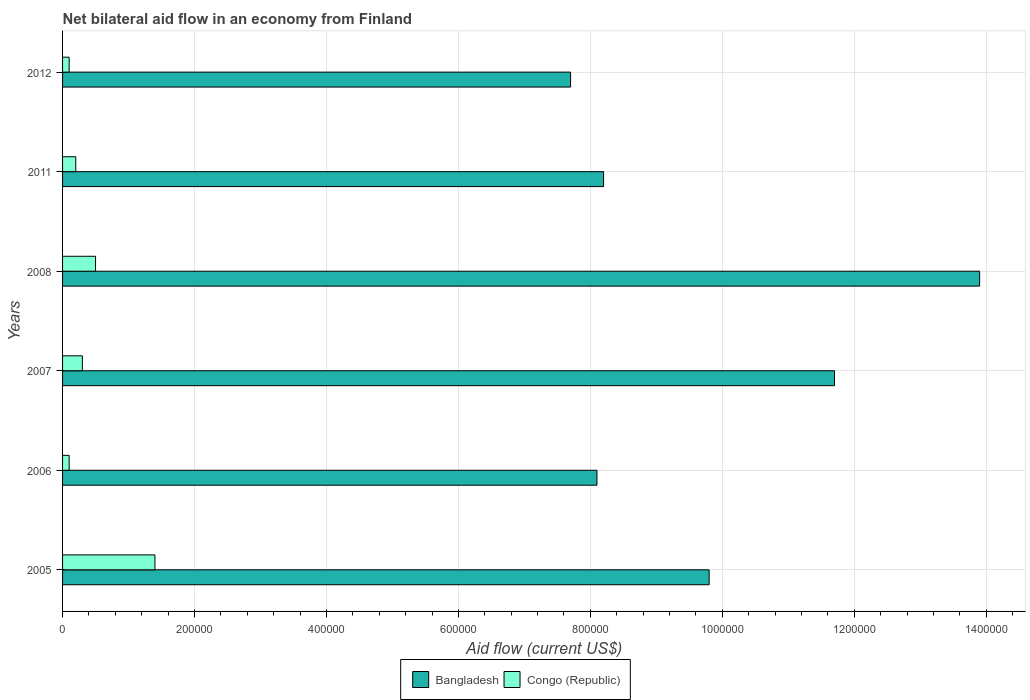How many different coloured bars are there?
Your response must be concise. 2. How many groups of bars are there?
Offer a very short reply. 6. Are the number of bars on each tick of the Y-axis equal?
Offer a very short reply. Yes. What is the label of the 2nd group of bars from the top?
Your response must be concise. 2011. What is the net bilateral aid flow in Bangladesh in 2008?
Your response must be concise. 1.39e+06. Across all years, what is the maximum net bilateral aid flow in Bangladesh?
Offer a terse response. 1.39e+06. Across all years, what is the minimum net bilateral aid flow in Bangladesh?
Ensure brevity in your answer.  7.70e+05. In which year was the net bilateral aid flow in Bangladesh minimum?
Provide a short and direct response. 2012. What is the total net bilateral aid flow in Bangladesh in the graph?
Ensure brevity in your answer.  5.94e+06. What is the difference between the net bilateral aid flow in Bangladesh in 2006 and the net bilateral aid flow in Congo (Republic) in 2007?
Your answer should be compact. 7.80e+05. What is the average net bilateral aid flow in Bangladesh per year?
Offer a terse response. 9.90e+05. In the year 2012, what is the difference between the net bilateral aid flow in Congo (Republic) and net bilateral aid flow in Bangladesh?
Provide a short and direct response. -7.60e+05. In how many years, is the net bilateral aid flow in Bangladesh greater than 320000 US$?
Provide a succinct answer. 6. What is the ratio of the net bilateral aid flow in Bangladesh in 2005 to that in 2012?
Offer a very short reply. 1.27. What is the difference between the highest and the lowest net bilateral aid flow in Congo (Republic)?
Give a very brief answer. 1.30e+05. In how many years, is the net bilateral aid flow in Bangladesh greater than the average net bilateral aid flow in Bangladesh taken over all years?
Give a very brief answer. 2. Is the sum of the net bilateral aid flow in Bangladesh in 2005 and 2011 greater than the maximum net bilateral aid flow in Congo (Republic) across all years?
Make the answer very short. Yes. What does the 1st bar from the top in 2005 represents?
Ensure brevity in your answer.  Congo (Republic). Are the values on the major ticks of X-axis written in scientific E-notation?
Ensure brevity in your answer.  No. Does the graph contain grids?
Make the answer very short. Yes. How many legend labels are there?
Offer a very short reply. 2. How are the legend labels stacked?
Offer a very short reply. Horizontal. What is the title of the graph?
Offer a very short reply. Net bilateral aid flow in an economy from Finland. Does "Guam" appear as one of the legend labels in the graph?
Ensure brevity in your answer.  No. What is the label or title of the Y-axis?
Offer a very short reply. Years. What is the Aid flow (current US$) of Bangladesh in 2005?
Offer a very short reply. 9.80e+05. What is the Aid flow (current US$) of Bangladesh in 2006?
Offer a terse response. 8.10e+05. What is the Aid flow (current US$) in Bangladesh in 2007?
Make the answer very short. 1.17e+06. What is the Aid flow (current US$) of Congo (Republic) in 2007?
Your answer should be very brief. 3.00e+04. What is the Aid flow (current US$) in Bangladesh in 2008?
Your response must be concise. 1.39e+06. What is the Aid flow (current US$) of Bangladesh in 2011?
Offer a very short reply. 8.20e+05. What is the Aid flow (current US$) of Bangladesh in 2012?
Your answer should be very brief. 7.70e+05. What is the Aid flow (current US$) of Congo (Republic) in 2012?
Give a very brief answer. 10000. Across all years, what is the maximum Aid flow (current US$) in Bangladesh?
Ensure brevity in your answer.  1.39e+06. Across all years, what is the maximum Aid flow (current US$) in Congo (Republic)?
Your answer should be compact. 1.40e+05. Across all years, what is the minimum Aid flow (current US$) of Bangladesh?
Give a very brief answer. 7.70e+05. Across all years, what is the minimum Aid flow (current US$) of Congo (Republic)?
Provide a succinct answer. 10000. What is the total Aid flow (current US$) of Bangladesh in the graph?
Provide a short and direct response. 5.94e+06. What is the difference between the Aid flow (current US$) in Bangladesh in 2005 and that in 2006?
Provide a short and direct response. 1.70e+05. What is the difference between the Aid flow (current US$) in Congo (Republic) in 2005 and that in 2006?
Offer a very short reply. 1.30e+05. What is the difference between the Aid flow (current US$) of Bangladesh in 2005 and that in 2007?
Offer a very short reply. -1.90e+05. What is the difference between the Aid flow (current US$) in Bangladesh in 2005 and that in 2008?
Provide a succinct answer. -4.10e+05. What is the difference between the Aid flow (current US$) of Congo (Republic) in 2005 and that in 2008?
Make the answer very short. 9.00e+04. What is the difference between the Aid flow (current US$) in Congo (Republic) in 2005 and that in 2011?
Give a very brief answer. 1.20e+05. What is the difference between the Aid flow (current US$) of Bangladesh in 2005 and that in 2012?
Give a very brief answer. 2.10e+05. What is the difference between the Aid flow (current US$) of Bangladesh in 2006 and that in 2007?
Your response must be concise. -3.60e+05. What is the difference between the Aid flow (current US$) of Congo (Republic) in 2006 and that in 2007?
Your response must be concise. -2.00e+04. What is the difference between the Aid flow (current US$) of Bangladesh in 2006 and that in 2008?
Make the answer very short. -5.80e+05. What is the difference between the Aid flow (current US$) in Congo (Republic) in 2006 and that in 2011?
Ensure brevity in your answer.  -10000. What is the difference between the Aid flow (current US$) in Bangladesh in 2006 and that in 2012?
Keep it short and to the point. 4.00e+04. What is the difference between the Aid flow (current US$) in Bangladesh in 2007 and that in 2008?
Your answer should be compact. -2.20e+05. What is the difference between the Aid flow (current US$) of Bangladesh in 2007 and that in 2011?
Provide a short and direct response. 3.50e+05. What is the difference between the Aid flow (current US$) of Congo (Republic) in 2007 and that in 2011?
Offer a very short reply. 10000. What is the difference between the Aid flow (current US$) of Bangladesh in 2007 and that in 2012?
Provide a succinct answer. 4.00e+05. What is the difference between the Aid flow (current US$) in Bangladesh in 2008 and that in 2011?
Your answer should be compact. 5.70e+05. What is the difference between the Aid flow (current US$) of Bangladesh in 2008 and that in 2012?
Your answer should be very brief. 6.20e+05. What is the difference between the Aid flow (current US$) in Bangladesh in 2005 and the Aid flow (current US$) in Congo (Republic) in 2006?
Give a very brief answer. 9.70e+05. What is the difference between the Aid flow (current US$) of Bangladesh in 2005 and the Aid flow (current US$) of Congo (Republic) in 2007?
Make the answer very short. 9.50e+05. What is the difference between the Aid flow (current US$) of Bangladesh in 2005 and the Aid flow (current US$) of Congo (Republic) in 2008?
Keep it short and to the point. 9.30e+05. What is the difference between the Aid flow (current US$) of Bangladesh in 2005 and the Aid flow (current US$) of Congo (Republic) in 2011?
Give a very brief answer. 9.60e+05. What is the difference between the Aid flow (current US$) of Bangladesh in 2005 and the Aid flow (current US$) of Congo (Republic) in 2012?
Keep it short and to the point. 9.70e+05. What is the difference between the Aid flow (current US$) of Bangladesh in 2006 and the Aid flow (current US$) of Congo (Republic) in 2007?
Keep it short and to the point. 7.80e+05. What is the difference between the Aid flow (current US$) in Bangladesh in 2006 and the Aid flow (current US$) in Congo (Republic) in 2008?
Provide a short and direct response. 7.60e+05. What is the difference between the Aid flow (current US$) of Bangladesh in 2006 and the Aid flow (current US$) of Congo (Republic) in 2011?
Offer a terse response. 7.90e+05. What is the difference between the Aid flow (current US$) in Bangladesh in 2006 and the Aid flow (current US$) in Congo (Republic) in 2012?
Your answer should be compact. 8.00e+05. What is the difference between the Aid flow (current US$) in Bangladesh in 2007 and the Aid flow (current US$) in Congo (Republic) in 2008?
Your answer should be compact. 1.12e+06. What is the difference between the Aid flow (current US$) in Bangladesh in 2007 and the Aid flow (current US$) in Congo (Republic) in 2011?
Your answer should be very brief. 1.15e+06. What is the difference between the Aid flow (current US$) in Bangladesh in 2007 and the Aid flow (current US$) in Congo (Republic) in 2012?
Ensure brevity in your answer.  1.16e+06. What is the difference between the Aid flow (current US$) in Bangladesh in 2008 and the Aid flow (current US$) in Congo (Republic) in 2011?
Provide a short and direct response. 1.37e+06. What is the difference between the Aid flow (current US$) in Bangladesh in 2008 and the Aid flow (current US$) in Congo (Republic) in 2012?
Offer a terse response. 1.38e+06. What is the difference between the Aid flow (current US$) of Bangladesh in 2011 and the Aid flow (current US$) of Congo (Republic) in 2012?
Your response must be concise. 8.10e+05. What is the average Aid flow (current US$) in Bangladesh per year?
Give a very brief answer. 9.90e+05. What is the average Aid flow (current US$) in Congo (Republic) per year?
Your response must be concise. 4.33e+04. In the year 2005, what is the difference between the Aid flow (current US$) in Bangladesh and Aid flow (current US$) in Congo (Republic)?
Keep it short and to the point. 8.40e+05. In the year 2006, what is the difference between the Aid flow (current US$) in Bangladesh and Aid flow (current US$) in Congo (Republic)?
Offer a terse response. 8.00e+05. In the year 2007, what is the difference between the Aid flow (current US$) of Bangladesh and Aid flow (current US$) of Congo (Republic)?
Provide a succinct answer. 1.14e+06. In the year 2008, what is the difference between the Aid flow (current US$) in Bangladesh and Aid flow (current US$) in Congo (Republic)?
Provide a short and direct response. 1.34e+06. In the year 2012, what is the difference between the Aid flow (current US$) of Bangladesh and Aid flow (current US$) of Congo (Republic)?
Keep it short and to the point. 7.60e+05. What is the ratio of the Aid flow (current US$) of Bangladesh in 2005 to that in 2006?
Ensure brevity in your answer.  1.21. What is the ratio of the Aid flow (current US$) in Congo (Republic) in 2005 to that in 2006?
Provide a short and direct response. 14. What is the ratio of the Aid flow (current US$) of Bangladesh in 2005 to that in 2007?
Make the answer very short. 0.84. What is the ratio of the Aid flow (current US$) of Congo (Republic) in 2005 to that in 2007?
Provide a short and direct response. 4.67. What is the ratio of the Aid flow (current US$) in Bangladesh in 2005 to that in 2008?
Make the answer very short. 0.7. What is the ratio of the Aid flow (current US$) of Bangladesh in 2005 to that in 2011?
Make the answer very short. 1.2. What is the ratio of the Aid flow (current US$) in Bangladesh in 2005 to that in 2012?
Give a very brief answer. 1.27. What is the ratio of the Aid flow (current US$) of Congo (Republic) in 2005 to that in 2012?
Offer a terse response. 14. What is the ratio of the Aid flow (current US$) of Bangladesh in 2006 to that in 2007?
Keep it short and to the point. 0.69. What is the ratio of the Aid flow (current US$) in Bangladesh in 2006 to that in 2008?
Your response must be concise. 0.58. What is the ratio of the Aid flow (current US$) of Bangladesh in 2006 to that in 2011?
Your answer should be compact. 0.99. What is the ratio of the Aid flow (current US$) of Congo (Republic) in 2006 to that in 2011?
Your response must be concise. 0.5. What is the ratio of the Aid flow (current US$) of Bangladesh in 2006 to that in 2012?
Your answer should be very brief. 1.05. What is the ratio of the Aid flow (current US$) in Congo (Republic) in 2006 to that in 2012?
Your answer should be very brief. 1. What is the ratio of the Aid flow (current US$) in Bangladesh in 2007 to that in 2008?
Offer a terse response. 0.84. What is the ratio of the Aid flow (current US$) of Bangladesh in 2007 to that in 2011?
Your response must be concise. 1.43. What is the ratio of the Aid flow (current US$) in Congo (Republic) in 2007 to that in 2011?
Offer a terse response. 1.5. What is the ratio of the Aid flow (current US$) in Bangladesh in 2007 to that in 2012?
Offer a very short reply. 1.52. What is the ratio of the Aid flow (current US$) of Congo (Republic) in 2007 to that in 2012?
Your answer should be very brief. 3. What is the ratio of the Aid flow (current US$) in Bangladesh in 2008 to that in 2011?
Give a very brief answer. 1.7. What is the ratio of the Aid flow (current US$) in Congo (Republic) in 2008 to that in 2011?
Your response must be concise. 2.5. What is the ratio of the Aid flow (current US$) of Bangladesh in 2008 to that in 2012?
Provide a short and direct response. 1.81. What is the ratio of the Aid flow (current US$) of Congo (Republic) in 2008 to that in 2012?
Provide a succinct answer. 5. What is the ratio of the Aid flow (current US$) in Bangladesh in 2011 to that in 2012?
Offer a very short reply. 1.06. What is the difference between the highest and the second highest Aid flow (current US$) of Bangladesh?
Provide a short and direct response. 2.20e+05. What is the difference between the highest and the lowest Aid flow (current US$) of Bangladesh?
Make the answer very short. 6.20e+05. 